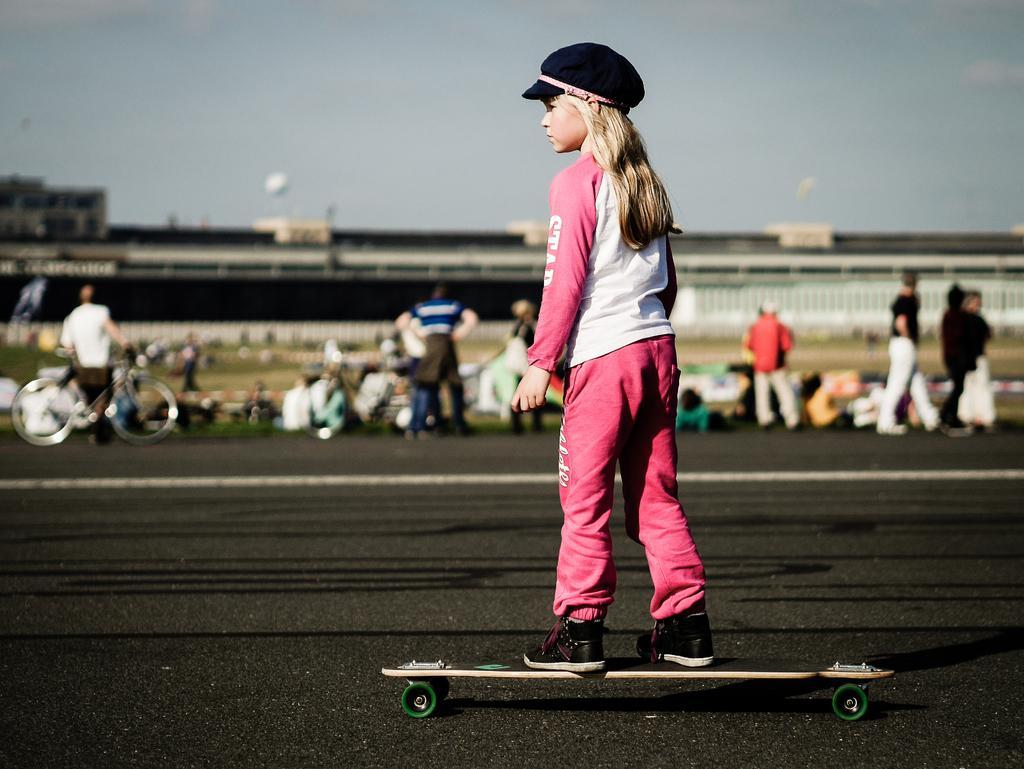Describe this image in one or two sentences. In this picture I can observe a girl on the skateboard in the middle of the picture. In the background there are some people and I can observe sky. 